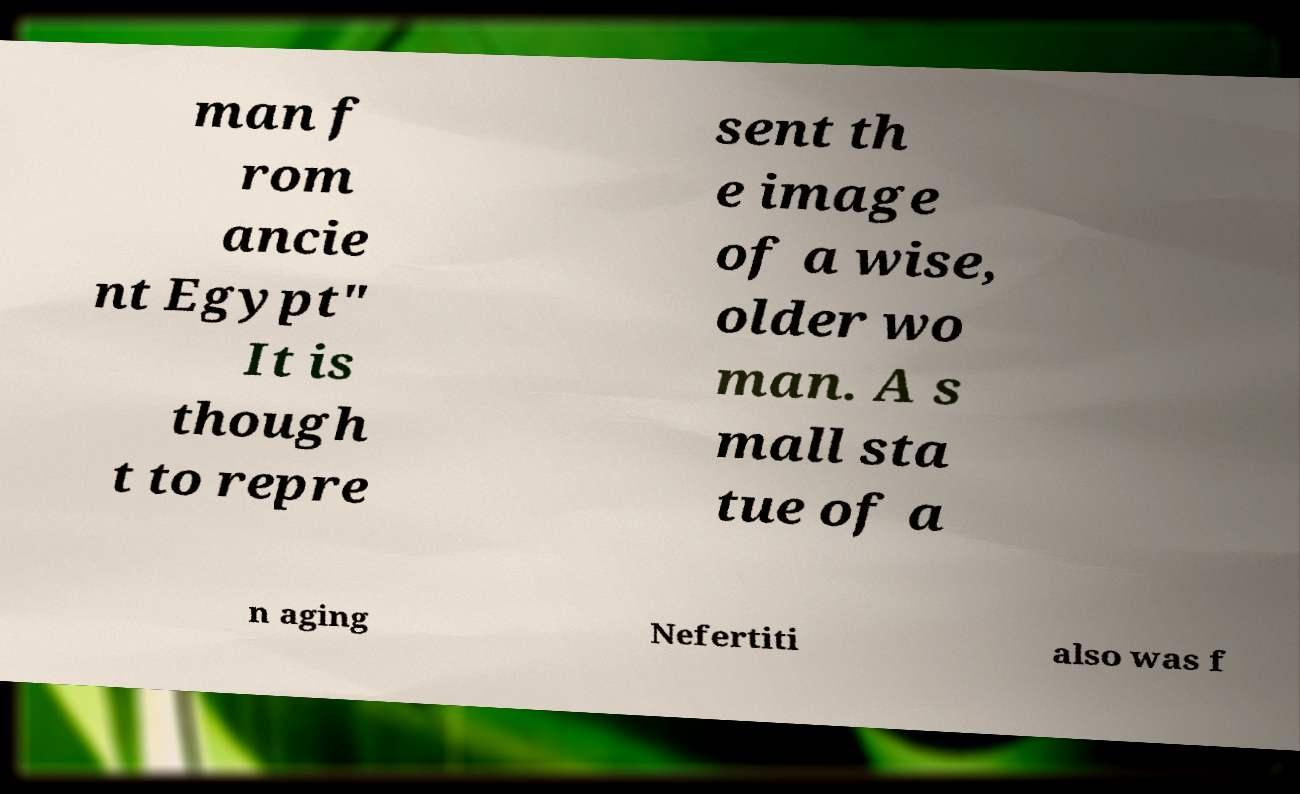Can you accurately transcribe the text from the provided image for me? man f rom ancie nt Egypt" It is though t to repre sent th e image of a wise, older wo man. A s mall sta tue of a n aging Nefertiti also was f 